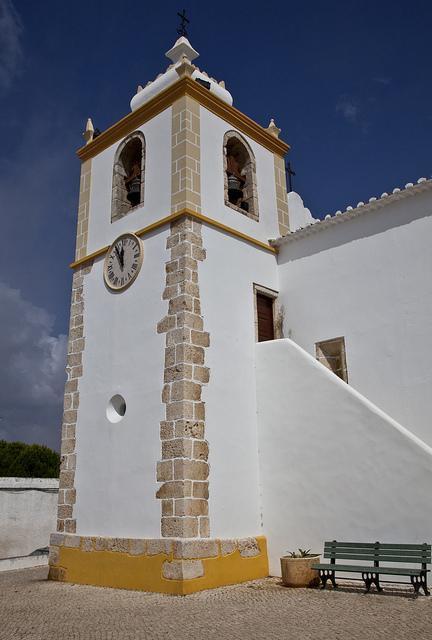How many benches can be seen?
Give a very brief answer. 1. How many balls does this dog have in its mouth?
Give a very brief answer. 0. 